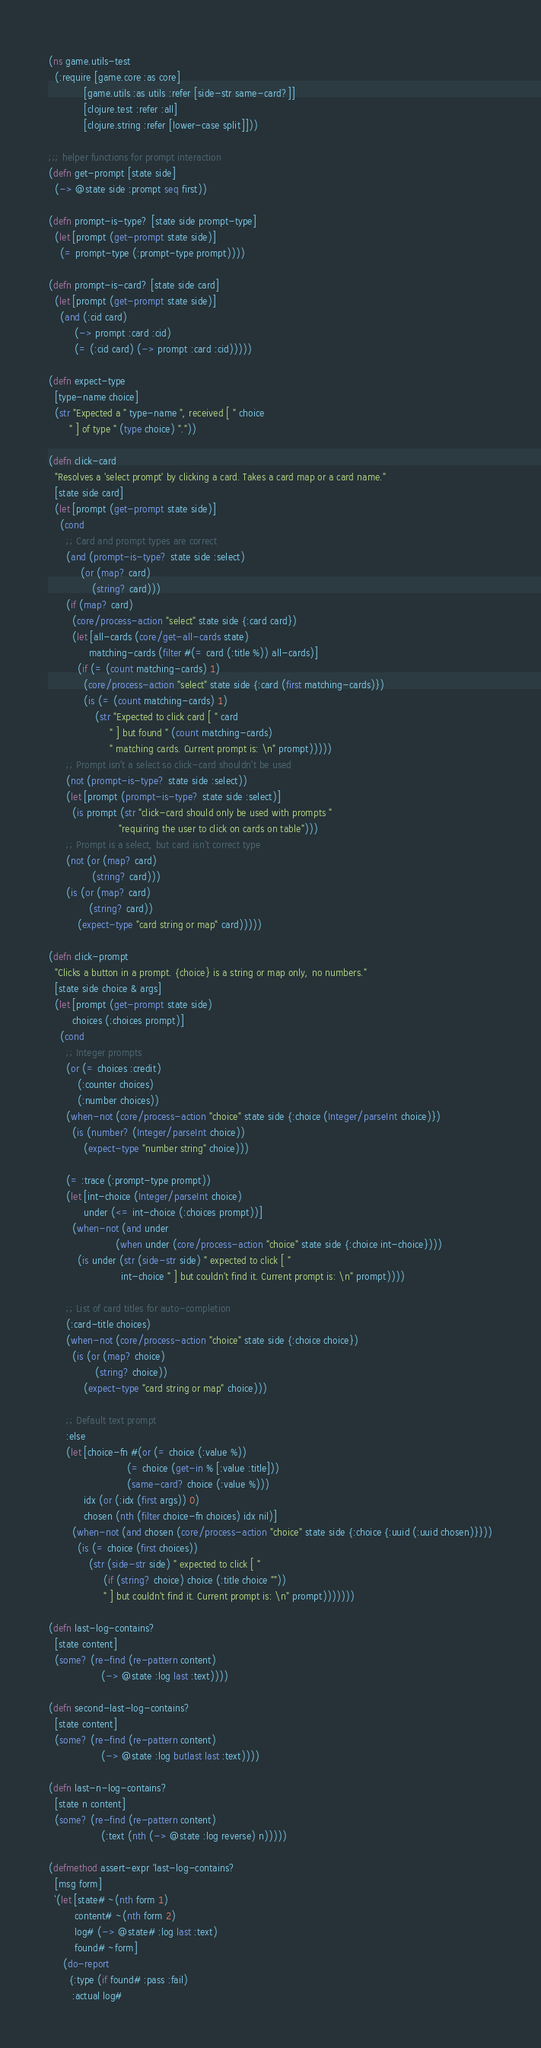Convert code to text. <code><loc_0><loc_0><loc_500><loc_500><_Clojure_>(ns game.utils-test
  (:require [game.core :as core]
            [game.utils :as utils :refer [side-str same-card?]]
            [clojure.test :refer :all]
            [clojure.string :refer [lower-case split]]))

;;; helper functions for prompt interaction
(defn get-prompt [state side]
  (-> @state side :prompt seq first))

(defn prompt-is-type? [state side prompt-type]
  (let [prompt (get-prompt state side)]
    (= prompt-type (:prompt-type prompt))))

(defn prompt-is-card? [state side card]
  (let [prompt (get-prompt state side)]
    (and (:cid card)
         (-> prompt :card :cid)
         (= (:cid card) (-> prompt :card :cid)))))

(defn expect-type
  [type-name choice]
  (str "Expected a " type-name ", received [ " choice
       " ] of type " (type choice) "."))

(defn click-card
  "Resolves a 'select prompt' by clicking a card. Takes a card map or a card name."
  [state side card]
  (let [prompt (get-prompt state side)]
    (cond
      ;; Card and prompt types are correct
      (and (prompt-is-type? state side :select)
           (or (map? card)
               (string? card)))
      (if (map? card)
        (core/process-action "select" state side {:card card})
        (let [all-cards (core/get-all-cards state)
              matching-cards (filter #(= card (:title %)) all-cards)]
          (if (= (count matching-cards) 1)
            (core/process-action "select" state side {:card (first matching-cards)})
            (is (= (count matching-cards) 1)
                (str "Expected to click card [ " card
                     " ] but found " (count matching-cards)
                     " matching cards. Current prompt is: \n" prompt)))))
      ;; Prompt isn't a select so click-card shouldn't be used
      (not (prompt-is-type? state side :select))
      (let [prompt (prompt-is-type? state side :select)]
        (is prompt (str "click-card should only be used with prompts "
                        "requiring the user to click on cards on table")))
      ;; Prompt is a select, but card isn't correct type
      (not (or (map? card)
               (string? card)))
      (is (or (map? card)
              (string? card))
          (expect-type "card string or map" card)))))

(defn click-prompt
  "Clicks a button in a prompt. {choice} is a string or map only, no numbers."
  [state side choice & args]
  (let [prompt (get-prompt state side)
        choices (:choices prompt)]
    (cond
      ;; Integer prompts
      (or (= choices :credit)
          (:counter choices)
          (:number choices))
      (when-not (core/process-action "choice" state side {:choice (Integer/parseInt choice)})
        (is (number? (Integer/parseInt choice))
            (expect-type "number string" choice)))

      (= :trace (:prompt-type prompt))
      (let [int-choice (Integer/parseInt choice)
            under (<= int-choice (:choices prompt))]
        (when-not (and under
                       (when under (core/process-action "choice" state side {:choice int-choice})))
          (is under (str (side-str side) " expected to click [ "
                         int-choice " ] but couldn't find it. Current prompt is: \n" prompt))))

      ;; List of card titles for auto-completion
      (:card-title choices)
      (when-not (core/process-action "choice" state side {:choice choice})
        (is (or (map? choice)
                (string? choice))
            (expect-type "card string or map" choice)))

      ;; Default text prompt
      :else
      (let [choice-fn #(or (= choice (:value %))
                           (= choice (get-in % [:value :title]))
                           (same-card? choice (:value %)))
            idx (or (:idx (first args)) 0)
            chosen (nth (filter choice-fn choices) idx nil)]
        (when-not (and chosen (core/process-action "choice" state side {:choice {:uuid (:uuid chosen)}}))
          (is (= choice (first choices))
              (str (side-str side) " expected to click [ "
                   (if (string? choice) choice (:title choice ""))
                   " ] but couldn't find it. Current prompt is: \n" prompt)))))))

(defn last-log-contains?
  [state content]
  (some? (re-find (re-pattern content)
                  (-> @state :log last :text))))

(defn second-last-log-contains?
  [state content]
  (some? (re-find (re-pattern content)
                  (-> @state :log butlast last :text))))

(defn last-n-log-contains?
  [state n content]
  (some? (re-find (re-pattern content)
                  (:text (nth (-> @state :log reverse) n)))))

(defmethod assert-expr 'last-log-contains?
  [msg form]
  `(let [state# ~(nth form 1)
         content# ~(nth form 2)
         log# (-> @state# :log last :text)
         found# ~form]
     (do-report
       {:type (if found# :pass :fail)
        :actual log#</code> 